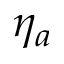Convert formula to latex. <formula><loc_0><loc_0><loc_500><loc_500>\eta _ { a }</formula> 